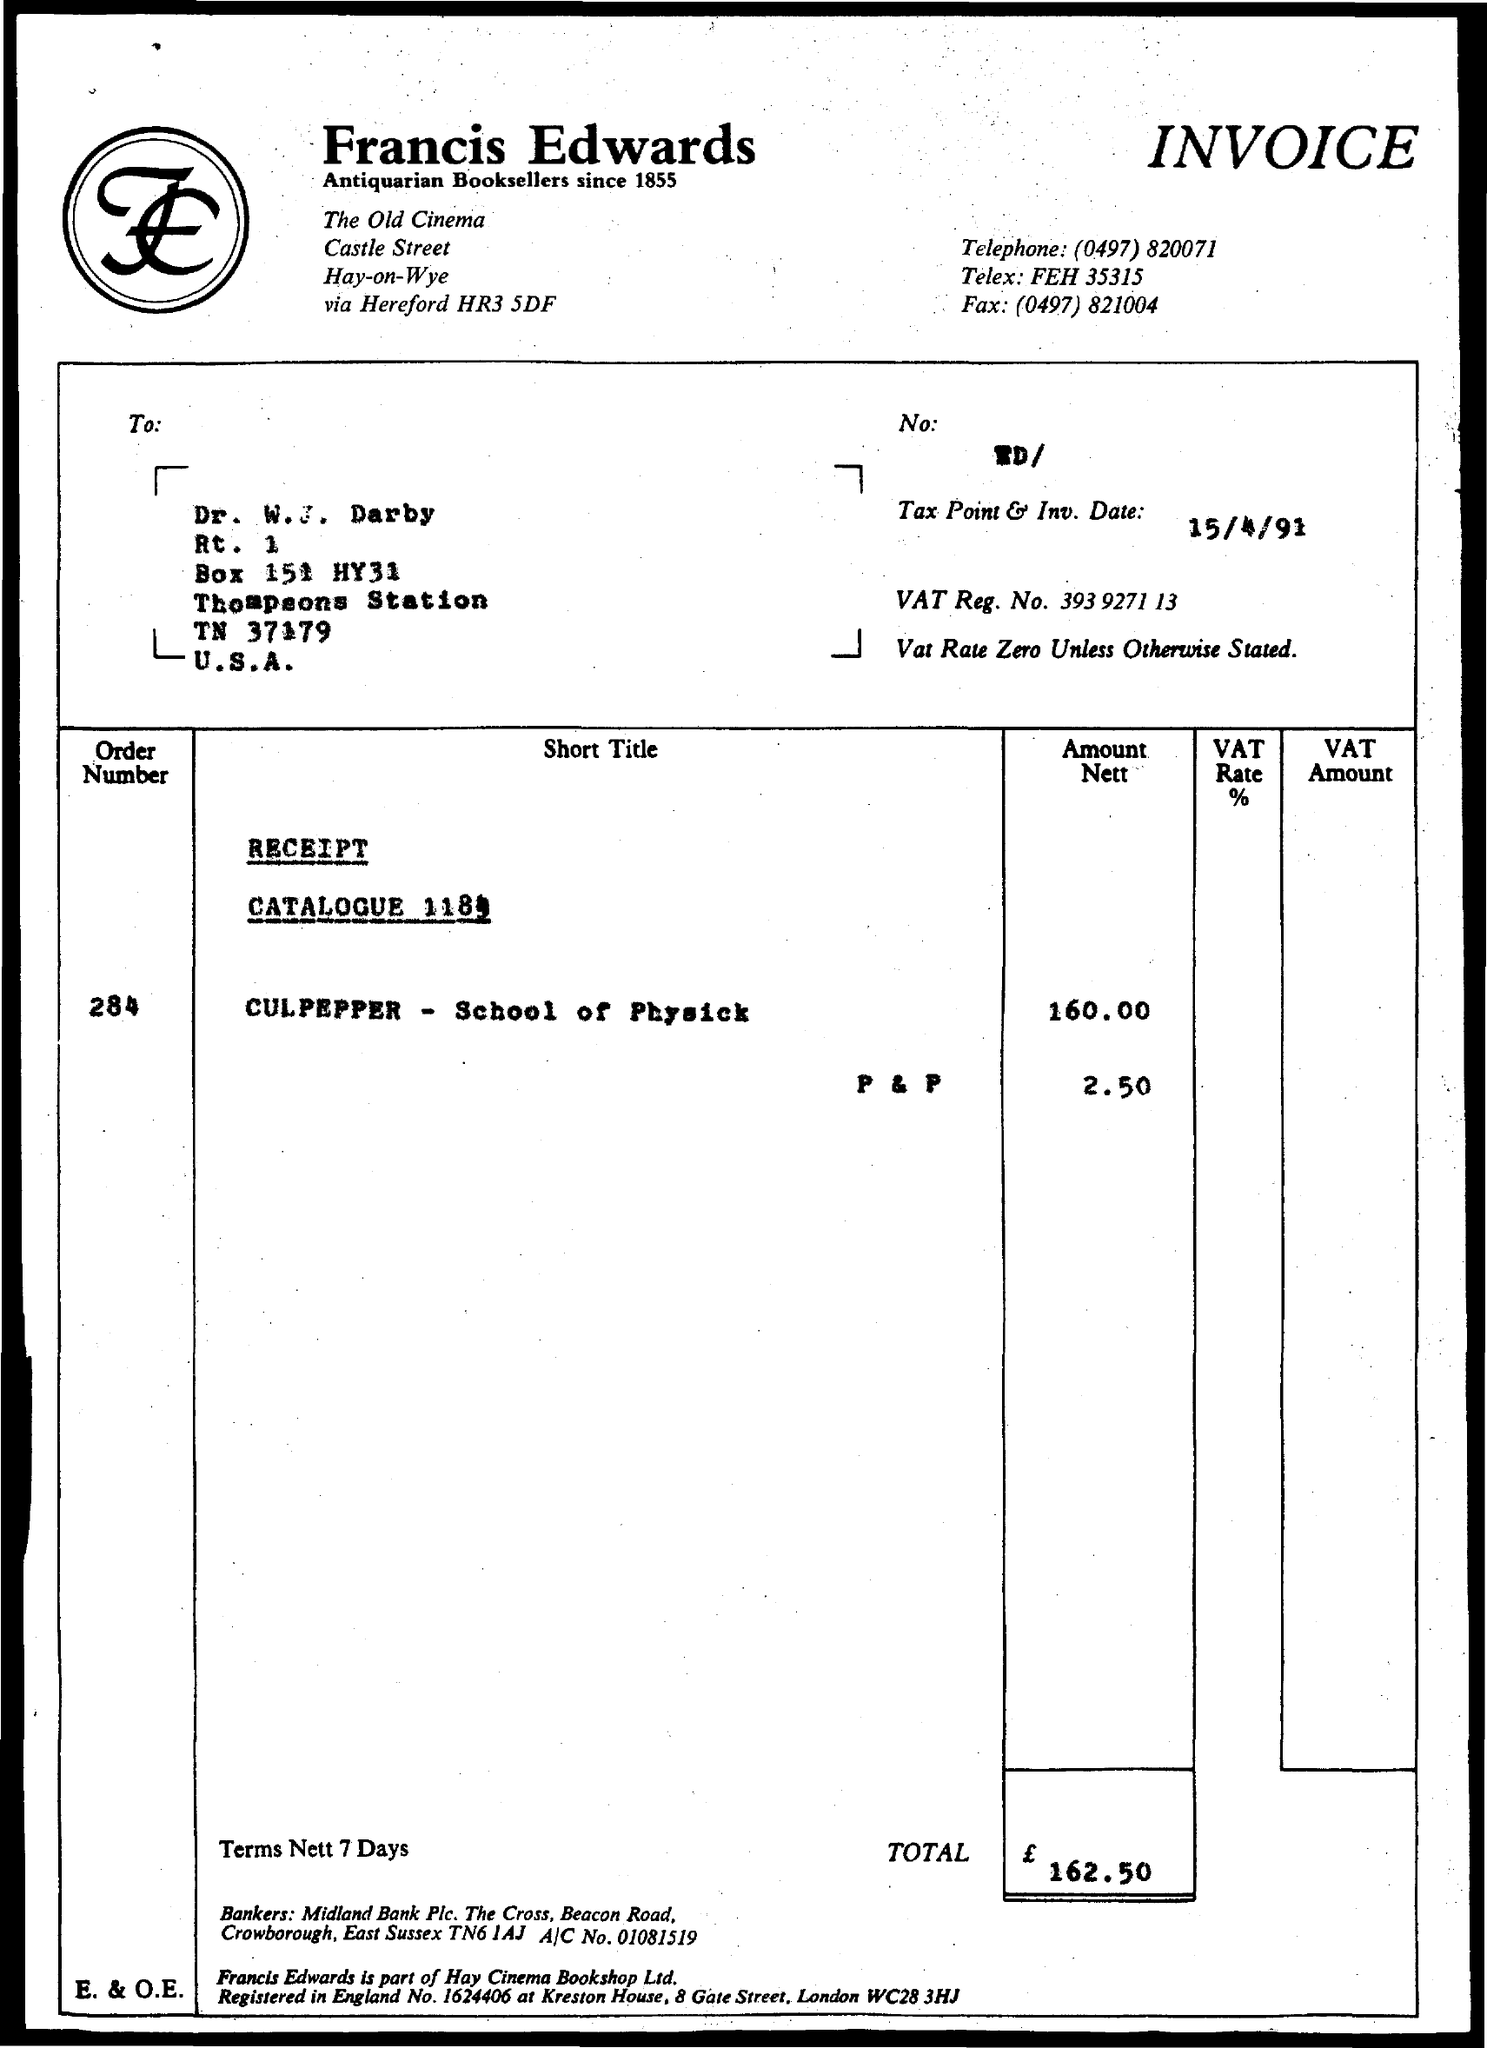What is the order number?
Offer a terse response. 284. What is the telephone number of the shop?
Your response must be concise. (0497) 820071. What is the VAT Reg. No.?
Your answer should be compact. 393 9271 13. What is the Tax Point & Inv. Date?
Provide a short and direct response. 15/4/91. 